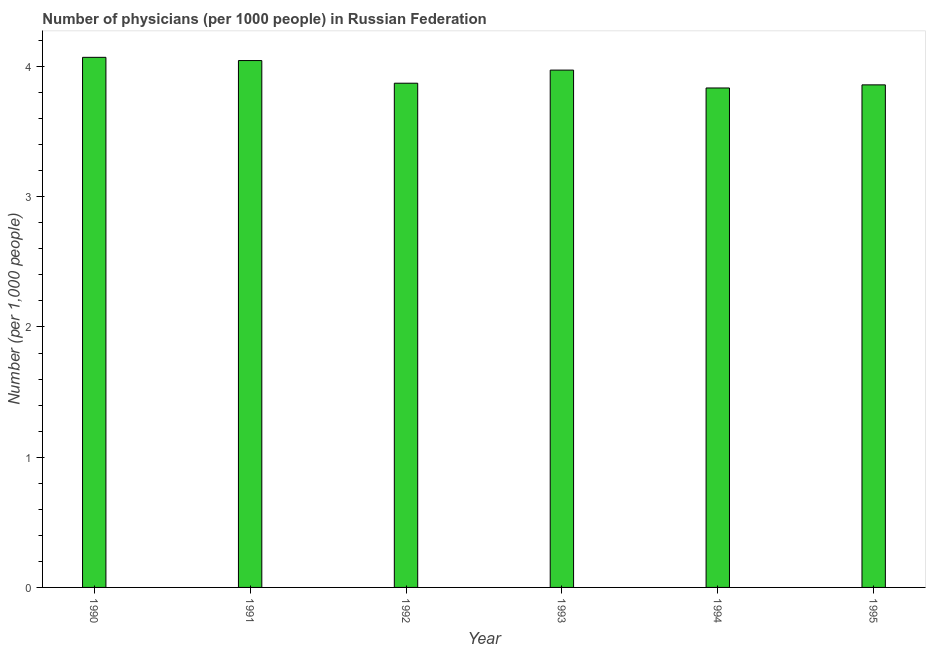Does the graph contain grids?
Give a very brief answer. No. What is the title of the graph?
Provide a succinct answer. Number of physicians (per 1000 people) in Russian Federation. What is the label or title of the Y-axis?
Ensure brevity in your answer.  Number (per 1,0 people). What is the number of physicians in 1990?
Ensure brevity in your answer.  4.07. Across all years, what is the maximum number of physicians?
Ensure brevity in your answer.  4.07. Across all years, what is the minimum number of physicians?
Provide a short and direct response. 3.84. What is the sum of the number of physicians?
Offer a terse response. 23.65. What is the difference between the number of physicians in 1990 and 1991?
Offer a terse response. 0.03. What is the average number of physicians per year?
Make the answer very short. 3.94. What is the median number of physicians?
Keep it short and to the point. 3.92. Is the number of physicians in 1990 less than that in 1994?
Provide a succinct answer. No. Is the difference between the number of physicians in 1990 and 1995 greater than the difference between any two years?
Your answer should be very brief. No. What is the difference between the highest and the second highest number of physicians?
Keep it short and to the point. 0.03. What is the difference between the highest and the lowest number of physicians?
Your answer should be compact. 0.24. In how many years, is the number of physicians greater than the average number of physicians taken over all years?
Make the answer very short. 3. How many bars are there?
Offer a very short reply. 6. How many years are there in the graph?
Ensure brevity in your answer.  6. What is the difference between two consecutive major ticks on the Y-axis?
Make the answer very short. 1. What is the Number (per 1,000 people) in 1990?
Keep it short and to the point. 4.07. What is the Number (per 1,000 people) in 1991?
Give a very brief answer. 4.05. What is the Number (per 1,000 people) in 1992?
Provide a succinct answer. 3.87. What is the Number (per 1,000 people) of 1993?
Provide a succinct answer. 3.97. What is the Number (per 1,000 people) of 1994?
Offer a very short reply. 3.84. What is the Number (per 1,000 people) in 1995?
Give a very brief answer. 3.86. What is the difference between the Number (per 1,000 people) in 1990 and 1991?
Your response must be concise. 0.02. What is the difference between the Number (per 1,000 people) in 1990 and 1992?
Your answer should be compact. 0.2. What is the difference between the Number (per 1,000 people) in 1990 and 1993?
Provide a succinct answer. 0.1. What is the difference between the Number (per 1,000 people) in 1990 and 1994?
Provide a short and direct response. 0.24. What is the difference between the Number (per 1,000 people) in 1990 and 1995?
Your response must be concise. 0.21. What is the difference between the Number (per 1,000 people) in 1991 and 1992?
Your answer should be compact. 0.17. What is the difference between the Number (per 1,000 people) in 1991 and 1993?
Keep it short and to the point. 0.07. What is the difference between the Number (per 1,000 people) in 1991 and 1994?
Make the answer very short. 0.21. What is the difference between the Number (per 1,000 people) in 1991 and 1995?
Offer a terse response. 0.19. What is the difference between the Number (per 1,000 people) in 1992 and 1993?
Keep it short and to the point. -0.1. What is the difference between the Number (per 1,000 people) in 1992 and 1994?
Your response must be concise. 0.04. What is the difference between the Number (per 1,000 people) in 1992 and 1995?
Your response must be concise. 0.01. What is the difference between the Number (per 1,000 people) in 1993 and 1994?
Keep it short and to the point. 0.14. What is the difference between the Number (per 1,000 people) in 1993 and 1995?
Give a very brief answer. 0.11. What is the difference between the Number (per 1,000 people) in 1994 and 1995?
Keep it short and to the point. -0.02. What is the ratio of the Number (per 1,000 people) in 1990 to that in 1991?
Give a very brief answer. 1.01. What is the ratio of the Number (per 1,000 people) in 1990 to that in 1992?
Keep it short and to the point. 1.05. What is the ratio of the Number (per 1,000 people) in 1990 to that in 1994?
Provide a succinct answer. 1.06. What is the ratio of the Number (per 1,000 people) in 1990 to that in 1995?
Provide a short and direct response. 1.05. What is the ratio of the Number (per 1,000 people) in 1991 to that in 1992?
Ensure brevity in your answer.  1.04. What is the ratio of the Number (per 1,000 people) in 1991 to that in 1994?
Give a very brief answer. 1.05. What is the ratio of the Number (per 1,000 people) in 1991 to that in 1995?
Your response must be concise. 1.05. What is the ratio of the Number (per 1,000 people) in 1992 to that in 1994?
Offer a very short reply. 1.01. What is the ratio of the Number (per 1,000 people) in 1992 to that in 1995?
Keep it short and to the point. 1. What is the ratio of the Number (per 1,000 people) in 1993 to that in 1994?
Your response must be concise. 1.04. What is the ratio of the Number (per 1,000 people) in 1993 to that in 1995?
Offer a terse response. 1.03. 